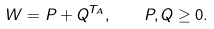<formula> <loc_0><loc_0><loc_500><loc_500>W = P + Q ^ { T _ { A } } , \quad P , Q \geq 0 .</formula> 